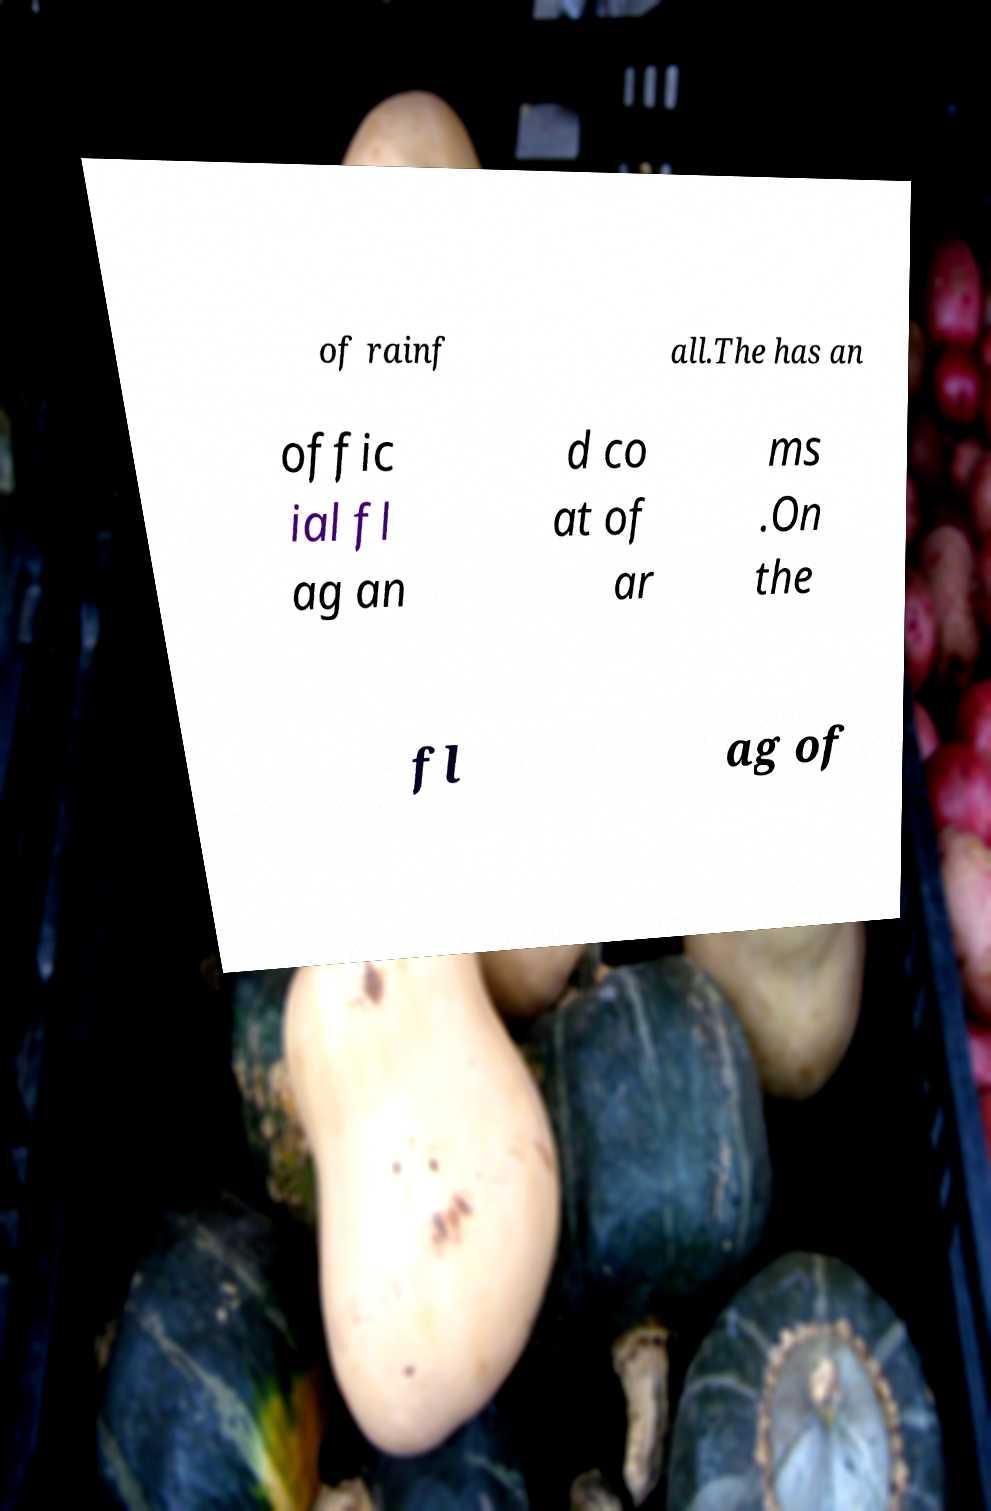There's text embedded in this image that I need extracted. Can you transcribe it verbatim? of rainf all.The has an offic ial fl ag an d co at of ar ms .On the fl ag of 